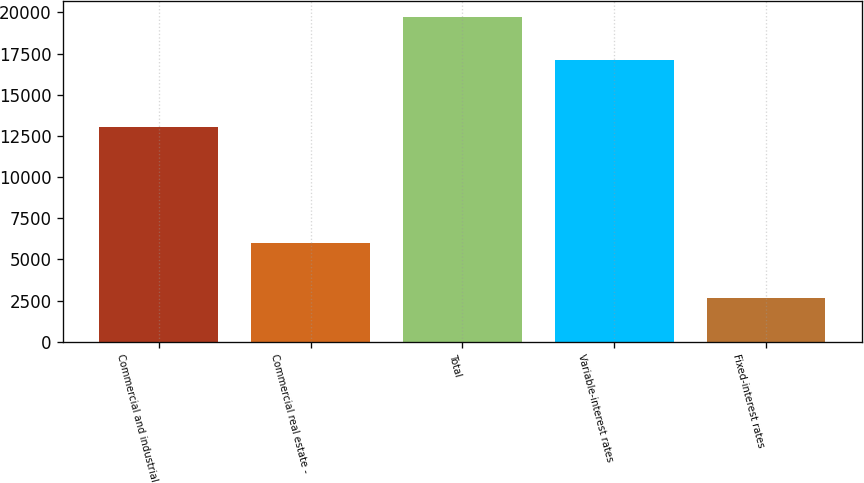Convert chart to OTSL. <chart><loc_0><loc_0><loc_500><loc_500><bar_chart><fcel>Commercial and industrial<fcel>Commercial real estate -<fcel>Total<fcel>Variable-interest rates<fcel>Fixed-interest rates<nl><fcel>13063<fcel>6001<fcel>19714<fcel>17084<fcel>2630<nl></chart> 